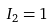Convert formula to latex. <formula><loc_0><loc_0><loc_500><loc_500>I _ { 2 } = 1</formula> 